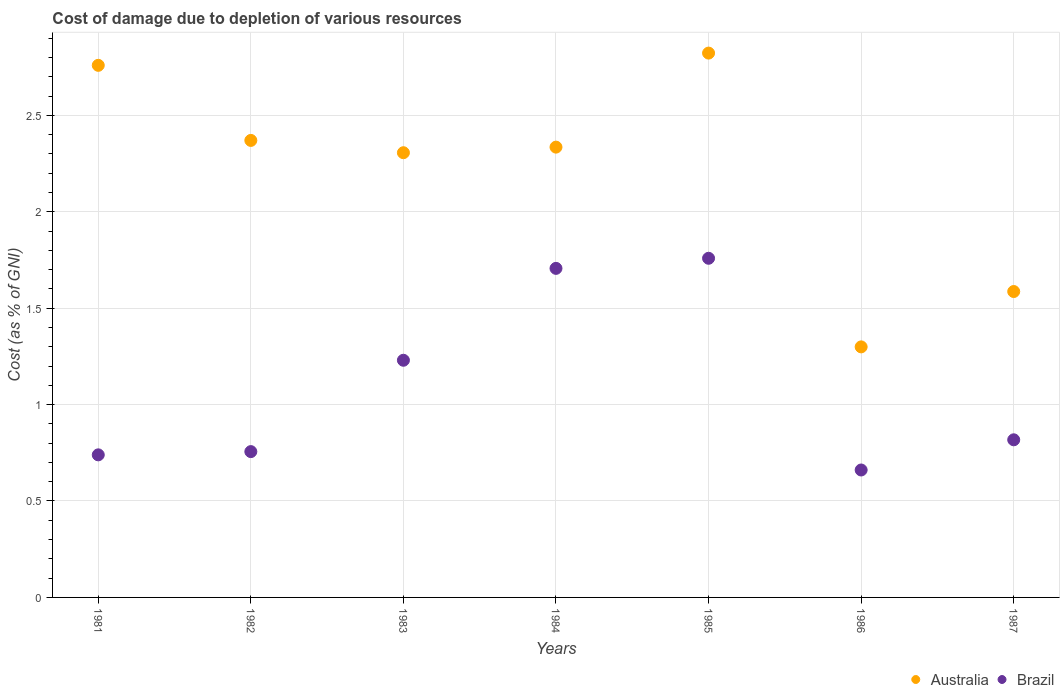What is the cost of damage caused due to the depletion of various resources in Brazil in 1984?
Offer a very short reply. 1.71. Across all years, what is the maximum cost of damage caused due to the depletion of various resources in Brazil?
Ensure brevity in your answer.  1.76. Across all years, what is the minimum cost of damage caused due to the depletion of various resources in Brazil?
Give a very brief answer. 0.66. In which year was the cost of damage caused due to the depletion of various resources in Australia minimum?
Offer a terse response. 1986. What is the total cost of damage caused due to the depletion of various resources in Brazil in the graph?
Your answer should be compact. 7.67. What is the difference between the cost of damage caused due to the depletion of various resources in Brazil in 1982 and that in 1984?
Ensure brevity in your answer.  -0.95. What is the difference between the cost of damage caused due to the depletion of various resources in Brazil in 1985 and the cost of damage caused due to the depletion of various resources in Australia in 1983?
Offer a very short reply. -0.55. What is the average cost of damage caused due to the depletion of various resources in Brazil per year?
Provide a succinct answer. 1.1. In the year 1986, what is the difference between the cost of damage caused due to the depletion of various resources in Australia and cost of damage caused due to the depletion of various resources in Brazil?
Provide a succinct answer. 0.64. In how many years, is the cost of damage caused due to the depletion of various resources in Brazil greater than 0.7 %?
Your answer should be very brief. 6. What is the ratio of the cost of damage caused due to the depletion of various resources in Brazil in 1981 to that in 1982?
Make the answer very short. 0.98. What is the difference between the highest and the second highest cost of damage caused due to the depletion of various resources in Australia?
Provide a succinct answer. 0.06. What is the difference between the highest and the lowest cost of damage caused due to the depletion of various resources in Brazil?
Provide a short and direct response. 1.1. Is the sum of the cost of damage caused due to the depletion of various resources in Brazil in 1981 and 1987 greater than the maximum cost of damage caused due to the depletion of various resources in Australia across all years?
Provide a succinct answer. No. Is the cost of damage caused due to the depletion of various resources in Australia strictly greater than the cost of damage caused due to the depletion of various resources in Brazil over the years?
Provide a succinct answer. Yes. Is the cost of damage caused due to the depletion of various resources in Brazil strictly less than the cost of damage caused due to the depletion of various resources in Australia over the years?
Offer a terse response. Yes. How many dotlines are there?
Your answer should be very brief. 2. How many years are there in the graph?
Make the answer very short. 7. Does the graph contain grids?
Offer a terse response. Yes. How many legend labels are there?
Make the answer very short. 2. What is the title of the graph?
Offer a terse response. Cost of damage due to depletion of various resources. Does "Chad" appear as one of the legend labels in the graph?
Give a very brief answer. No. What is the label or title of the X-axis?
Offer a terse response. Years. What is the label or title of the Y-axis?
Ensure brevity in your answer.  Cost (as % of GNI). What is the Cost (as % of GNI) in Australia in 1981?
Provide a succinct answer. 2.76. What is the Cost (as % of GNI) in Brazil in 1981?
Offer a very short reply. 0.74. What is the Cost (as % of GNI) of Australia in 1982?
Make the answer very short. 2.37. What is the Cost (as % of GNI) in Brazil in 1982?
Your answer should be very brief. 0.76. What is the Cost (as % of GNI) in Australia in 1983?
Make the answer very short. 2.31. What is the Cost (as % of GNI) in Brazil in 1983?
Provide a short and direct response. 1.23. What is the Cost (as % of GNI) of Australia in 1984?
Your response must be concise. 2.33. What is the Cost (as % of GNI) in Brazil in 1984?
Provide a short and direct response. 1.71. What is the Cost (as % of GNI) of Australia in 1985?
Your response must be concise. 2.82. What is the Cost (as % of GNI) in Brazil in 1985?
Provide a succinct answer. 1.76. What is the Cost (as % of GNI) of Australia in 1986?
Give a very brief answer. 1.3. What is the Cost (as % of GNI) in Brazil in 1986?
Give a very brief answer. 0.66. What is the Cost (as % of GNI) of Australia in 1987?
Offer a terse response. 1.59. What is the Cost (as % of GNI) in Brazil in 1987?
Provide a succinct answer. 0.82. Across all years, what is the maximum Cost (as % of GNI) of Australia?
Provide a short and direct response. 2.82. Across all years, what is the maximum Cost (as % of GNI) of Brazil?
Provide a short and direct response. 1.76. Across all years, what is the minimum Cost (as % of GNI) of Australia?
Give a very brief answer. 1.3. Across all years, what is the minimum Cost (as % of GNI) in Brazil?
Provide a succinct answer. 0.66. What is the total Cost (as % of GNI) in Australia in the graph?
Your answer should be very brief. 15.48. What is the total Cost (as % of GNI) of Brazil in the graph?
Give a very brief answer. 7.67. What is the difference between the Cost (as % of GNI) in Australia in 1981 and that in 1982?
Provide a succinct answer. 0.39. What is the difference between the Cost (as % of GNI) in Brazil in 1981 and that in 1982?
Offer a very short reply. -0.02. What is the difference between the Cost (as % of GNI) of Australia in 1981 and that in 1983?
Keep it short and to the point. 0.45. What is the difference between the Cost (as % of GNI) of Brazil in 1981 and that in 1983?
Make the answer very short. -0.49. What is the difference between the Cost (as % of GNI) in Australia in 1981 and that in 1984?
Offer a terse response. 0.42. What is the difference between the Cost (as % of GNI) in Brazil in 1981 and that in 1984?
Provide a succinct answer. -0.97. What is the difference between the Cost (as % of GNI) of Australia in 1981 and that in 1985?
Offer a terse response. -0.06. What is the difference between the Cost (as % of GNI) of Brazil in 1981 and that in 1985?
Your response must be concise. -1.02. What is the difference between the Cost (as % of GNI) in Australia in 1981 and that in 1986?
Make the answer very short. 1.46. What is the difference between the Cost (as % of GNI) of Brazil in 1981 and that in 1986?
Keep it short and to the point. 0.08. What is the difference between the Cost (as % of GNI) of Australia in 1981 and that in 1987?
Your answer should be compact. 1.17. What is the difference between the Cost (as % of GNI) of Brazil in 1981 and that in 1987?
Your answer should be compact. -0.08. What is the difference between the Cost (as % of GNI) of Australia in 1982 and that in 1983?
Your answer should be compact. 0.06. What is the difference between the Cost (as % of GNI) in Brazil in 1982 and that in 1983?
Provide a short and direct response. -0.47. What is the difference between the Cost (as % of GNI) of Australia in 1982 and that in 1984?
Your answer should be compact. 0.03. What is the difference between the Cost (as % of GNI) of Brazil in 1982 and that in 1984?
Offer a very short reply. -0.95. What is the difference between the Cost (as % of GNI) of Australia in 1982 and that in 1985?
Make the answer very short. -0.45. What is the difference between the Cost (as % of GNI) in Brazil in 1982 and that in 1985?
Give a very brief answer. -1. What is the difference between the Cost (as % of GNI) of Australia in 1982 and that in 1986?
Give a very brief answer. 1.07. What is the difference between the Cost (as % of GNI) of Brazil in 1982 and that in 1986?
Ensure brevity in your answer.  0.1. What is the difference between the Cost (as % of GNI) in Australia in 1982 and that in 1987?
Your answer should be very brief. 0.78. What is the difference between the Cost (as % of GNI) in Brazil in 1982 and that in 1987?
Your answer should be very brief. -0.06. What is the difference between the Cost (as % of GNI) of Australia in 1983 and that in 1984?
Ensure brevity in your answer.  -0.03. What is the difference between the Cost (as % of GNI) in Brazil in 1983 and that in 1984?
Keep it short and to the point. -0.48. What is the difference between the Cost (as % of GNI) of Australia in 1983 and that in 1985?
Provide a short and direct response. -0.52. What is the difference between the Cost (as % of GNI) of Brazil in 1983 and that in 1985?
Keep it short and to the point. -0.53. What is the difference between the Cost (as % of GNI) of Australia in 1983 and that in 1986?
Ensure brevity in your answer.  1.01. What is the difference between the Cost (as % of GNI) of Brazil in 1983 and that in 1986?
Provide a short and direct response. 0.57. What is the difference between the Cost (as % of GNI) in Australia in 1983 and that in 1987?
Your answer should be compact. 0.72. What is the difference between the Cost (as % of GNI) in Brazil in 1983 and that in 1987?
Your answer should be compact. 0.41. What is the difference between the Cost (as % of GNI) of Australia in 1984 and that in 1985?
Offer a very short reply. -0.49. What is the difference between the Cost (as % of GNI) of Brazil in 1984 and that in 1985?
Your response must be concise. -0.05. What is the difference between the Cost (as % of GNI) of Australia in 1984 and that in 1986?
Your response must be concise. 1.04. What is the difference between the Cost (as % of GNI) in Brazil in 1984 and that in 1986?
Provide a succinct answer. 1.05. What is the difference between the Cost (as % of GNI) in Australia in 1984 and that in 1987?
Give a very brief answer. 0.75. What is the difference between the Cost (as % of GNI) in Australia in 1985 and that in 1986?
Provide a short and direct response. 1.52. What is the difference between the Cost (as % of GNI) in Brazil in 1985 and that in 1986?
Provide a short and direct response. 1.1. What is the difference between the Cost (as % of GNI) in Australia in 1985 and that in 1987?
Ensure brevity in your answer.  1.24. What is the difference between the Cost (as % of GNI) of Australia in 1986 and that in 1987?
Keep it short and to the point. -0.29. What is the difference between the Cost (as % of GNI) in Brazil in 1986 and that in 1987?
Give a very brief answer. -0.16. What is the difference between the Cost (as % of GNI) of Australia in 1981 and the Cost (as % of GNI) of Brazil in 1982?
Your response must be concise. 2. What is the difference between the Cost (as % of GNI) in Australia in 1981 and the Cost (as % of GNI) in Brazil in 1983?
Make the answer very short. 1.53. What is the difference between the Cost (as % of GNI) in Australia in 1981 and the Cost (as % of GNI) in Brazil in 1984?
Offer a terse response. 1.05. What is the difference between the Cost (as % of GNI) in Australia in 1981 and the Cost (as % of GNI) in Brazil in 1986?
Your response must be concise. 2.1. What is the difference between the Cost (as % of GNI) in Australia in 1981 and the Cost (as % of GNI) in Brazil in 1987?
Provide a short and direct response. 1.94. What is the difference between the Cost (as % of GNI) in Australia in 1982 and the Cost (as % of GNI) in Brazil in 1983?
Provide a succinct answer. 1.14. What is the difference between the Cost (as % of GNI) in Australia in 1982 and the Cost (as % of GNI) in Brazil in 1984?
Make the answer very short. 0.66. What is the difference between the Cost (as % of GNI) of Australia in 1982 and the Cost (as % of GNI) of Brazil in 1985?
Make the answer very short. 0.61. What is the difference between the Cost (as % of GNI) in Australia in 1982 and the Cost (as % of GNI) in Brazil in 1986?
Provide a succinct answer. 1.71. What is the difference between the Cost (as % of GNI) in Australia in 1982 and the Cost (as % of GNI) in Brazil in 1987?
Your response must be concise. 1.55. What is the difference between the Cost (as % of GNI) of Australia in 1983 and the Cost (as % of GNI) of Brazil in 1984?
Your answer should be very brief. 0.6. What is the difference between the Cost (as % of GNI) of Australia in 1983 and the Cost (as % of GNI) of Brazil in 1985?
Make the answer very short. 0.55. What is the difference between the Cost (as % of GNI) in Australia in 1983 and the Cost (as % of GNI) in Brazil in 1986?
Your answer should be compact. 1.65. What is the difference between the Cost (as % of GNI) in Australia in 1983 and the Cost (as % of GNI) in Brazil in 1987?
Your response must be concise. 1.49. What is the difference between the Cost (as % of GNI) of Australia in 1984 and the Cost (as % of GNI) of Brazil in 1985?
Give a very brief answer. 0.58. What is the difference between the Cost (as % of GNI) in Australia in 1984 and the Cost (as % of GNI) in Brazil in 1986?
Offer a very short reply. 1.67. What is the difference between the Cost (as % of GNI) of Australia in 1984 and the Cost (as % of GNI) of Brazil in 1987?
Provide a succinct answer. 1.52. What is the difference between the Cost (as % of GNI) of Australia in 1985 and the Cost (as % of GNI) of Brazil in 1986?
Provide a short and direct response. 2.16. What is the difference between the Cost (as % of GNI) of Australia in 1985 and the Cost (as % of GNI) of Brazil in 1987?
Give a very brief answer. 2.01. What is the difference between the Cost (as % of GNI) of Australia in 1986 and the Cost (as % of GNI) of Brazil in 1987?
Provide a short and direct response. 0.48. What is the average Cost (as % of GNI) of Australia per year?
Offer a terse response. 2.21. What is the average Cost (as % of GNI) of Brazil per year?
Offer a very short reply. 1.1. In the year 1981, what is the difference between the Cost (as % of GNI) in Australia and Cost (as % of GNI) in Brazil?
Make the answer very short. 2.02. In the year 1982, what is the difference between the Cost (as % of GNI) of Australia and Cost (as % of GNI) of Brazil?
Your answer should be compact. 1.61. In the year 1983, what is the difference between the Cost (as % of GNI) in Australia and Cost (as % of GNI) in Brazil?
Offer a very short reply. 1.08. In the year 1984, what is the difference between the Cost (as % of GNI) in Australia and Cost (as % of GNI) in Brazil?
Your answer should be very brief. 0.63. In the year 1985, what is the difference between the Cost (as % of GNI) in Australia and Cost (as % of GNI) in Brazil?
Your answer should be compact. 1.06. In the year 1986, what is the difference between the Cost (as % of GNI) of Australia and Cost (as % of GNI) of Brazil?
Your answer should be compact. 0.64. In the year 1987, what is the difference between the Cost (as % of GNI) of Australia and Cost (as % of GNI) of Brazil?
Keep it short and to the point. 0.77. What is the ratio of the Cost (as % of GNI) of Australia in 1981 to that in 1982?
Offer a terse response. 1.16. What is the ratio of the Cost (as % of GNI) of Brazil in 1981 to that in 1982?
Give a very brief answer. 0.98. What is the ratio of the Cost (as % of GNI) in Australia in 1981 to that in 1983?
Your response must be concise. 1.2. What is the ratio of the Cost (as % of GNI) in Brazil in 1981 to that in 1983?
Your answer should be compact. 0.6. What is the ratio of the Cost (as % of GNI) of Australia in 1981 to that in 1984?
Provide a short and direct response. 1.18. What is the ratio of the Cost (as % of GNI) of Brazil in 1981 to that in 1984?
Your answer should be very brief. 0.43. What is the ratio of the Cost (as % of GNI) in Australia in 1981 to that in 1985?
Provide a succinct answer. 0.98. What is the ratio of the Cost (as % of GNI) in Brazil in 1981 to that in 1985?
Your answer should be compact. 0.42. What is the ratio of the Cost (as % of GNI) in Australia in 1981 to that in 1986?
Provide a succinct answer. 2.12. What is the ratio of the Cost (as % of GNI) of Brazil in 1981 to that in 1986?
Keep it short and to the point. 1.12. What is the ratio of the Cost (as % of GNI) in Australia in 1981 to that in 1987?
Ensure brevity in your answer.  1.74. What is the ratio of the Cost (as % of GNI) of Brazil in 1981 to that in 1987?
Your answer should be compact. 0.9. What is the ratio of the Cost (as % of GNI) of Australia in 1982 to that in 1983?
Your response must be concise. 1.03. What is the ratio of the Cost (as % of GNI) in Brazil in 1982 to that in 1983?
Ensure brevity in your answer.  0.61. What is the ratio of the Cost (as % of GNI) in Australia in 1982 to that in 1984?
Your response must be concise. 1.01. What is the ratio of the Cost (as % of GNI) of Brazil in 1982 to that in 1984?
Ensure brevity in your answer.  0.44. What is the ratio of the Cost (as % of GNI) in Australia in 1982 to that in 1985?
Provide a short and direct response. 0.84. What is the ratio of the Cost (as % of GNI) of Brazil in 1982 to that in 1985?
Your answer should be compact. 0.43. What is the ratio of the Cost (as % of GNI) of Australia in 1982 to that in 1986?
Your answer should be compact. 1.82. What is the ratio of the Cost (as % of GNI) in Brazil in 1982 to that in 1986?
Provide a succinct answer. 1.14. What is the ratio of the Cost (as % of GNI) in Australia in 1982 to that in 1987?
Offer a very short reply. 1.49. What is the ratio of the Cost (as % of GNI) of Brazil in 1982 to that in 1987?
Provide a short and direct response. 0.93. What is the ratio of the Cost (as % of GNI) in Australia in 1983 to that in 1984?
Offer a terse response. 0.99. What is the ratio of the Cost (as % of GNI) in Brazil in 1983 to that in 1984?
Give a very brief answer. 0.72. What is the ratio of the Cost (as % of GNI) in Australia in 1983 to that in 1985?
Your answer should be very brief. 0.82. What is the ratio of the Cost (as % of GNI) in Brazil in 1983 to that in 1985?
Your answer should be compact. 0.7. What is the ratio of the Cost (as % of GNI) of Australia in 1983 to that in 1986?
Provide a succinct answer. 1.77. What is the ratio of the Cost (as % of GNI) in Brazil in 1983 to that in 1986?
Keep it short and to the point. 1.86. What is the ratio of the Cost (as % of GNI) of Australia in 1983 to that in 1987?
Ensure brevity in your answer.  1.45. What is the ratio of the Cost (as % of GNI) of Brazil in 1983 to that in 1987?
Provide a short and direct response. 1.5. What is the ratio of the Cost (as % of GNI) in Australia in 1984 to that in 1985?
Your response must be concise. 0.83. What is the ratio of the Cost (as % of GNI) of Brazil in 1984 to that in 1985?
Provide a short and direct response. 0.97. What is the ratio of the Cost (as % of GNI) in Australia in 1984 to that in 1986?
Your response must be concise. 1.8. What is the ratio of the Cost (as % of GNI) in Brazil in 1984 to that in 1986?
Offer a terse response. 2.58. What is the ratio of the Cost (as % of GNI) in Australia in 1984 to that in 1987?
Offer a very short reply. 1.47. What is the ratio of the Cost (as % of GNI) in Brazil in 1984 to that in 1987?
Your answer should be very brief. 2.09. What is the ratio of the Cost (as % of GNI) in Australia in 1985 to that in 1986?
Give a very brief answer. 2.17. What is the ratio of the Cost (as % of GNI) in Brazil in 1985 to that in 1986?
Keep it short and to the point. 2.66. What is the ratio of the Cost (as % of GNI) in Australia in 1985 to that in 1987?
Make the answer very short. 1.78. What is the ratio of the Cost (as % of GNI) in Brazil in 1985 to that in 1987?
Your answer should be compact. 2.15. What is the ratio of the Cost (as % of GNI) of Australia in 1986 to that in 1987?
Keep it short and to the point. 0.82. What is the ratio of the Cost (as % of GNI) of Brazil in 1986 to that in 1987?
Provide a succinct answer. 0.81. What is the difference between the highest and the second highest Cost (as % of GNI) in Australia?
Offer a terse response. 0.06. What is the difference between the highest and the second highest Cost (as % of GNI) in Brazil?
Ensure brevity in your answer.  0.05. What is the difference between the highest and the lowest Cost (as % of GNI) in Australia?
Make the answer very short. 1.52. What is the difference between the highest and the lowest Cost (as % of GNI) of Brazil?
Offer a very short reply. 1.1. 